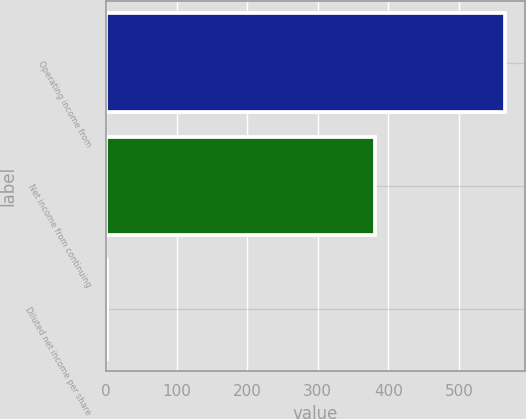Convert chart to OTSL. <chart><loc_0><loc_0><loc_500><loc_500><bar_chart><fcel>Operating income from<fcel>Net income from continuing<fcel>Diluted net income per share<nl><fcel>565.6<fcel>381<fcel>1.06<nl></chart> 